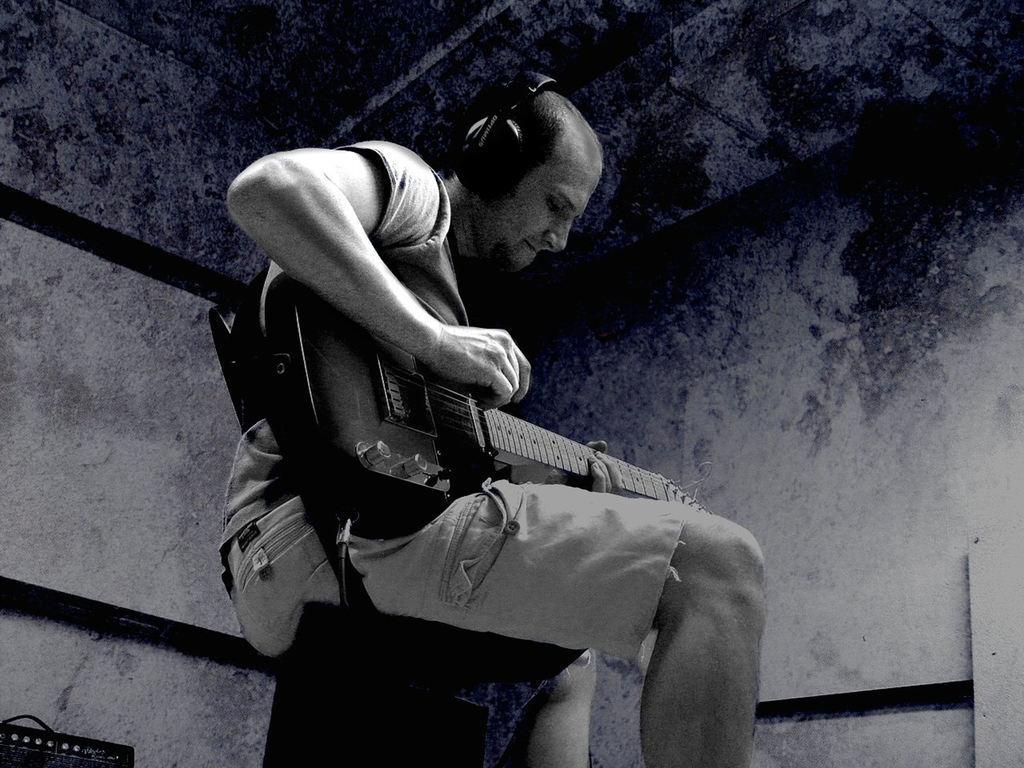How would you summarize this image in a sentence or two? In this picture there is a boy, who is sitting on the chair and playing the guitar, he has applied headphones over his head. 